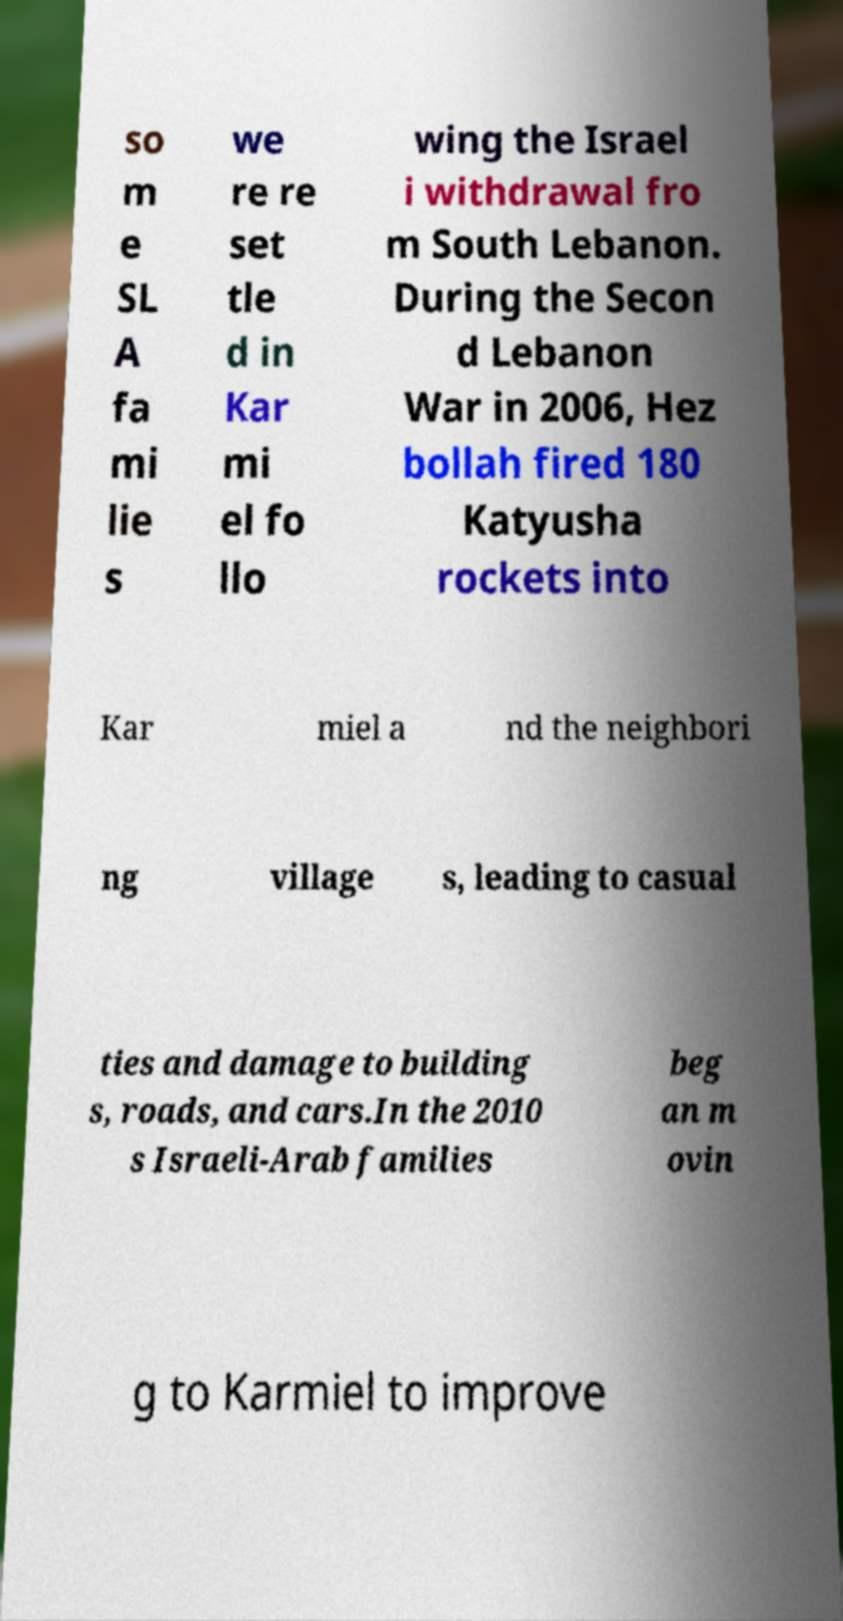Please read and relay the text visible in this image. What does it say? so m e SL A fa mi lie s we re re set tle d in Kar mi el fo llo wing the Israel i withdrawal fro m South Lebanon. During the Secon d Lebanon War in 2006, Hez bollah fired 180 Katyusha rockets into Kar miel a nd the neighbori ng village s, leading to casual ties and damage to building s, roads, and cars.In the 2010 s Israeli-Arab families beg an m ovin g to Karmiel to improve 